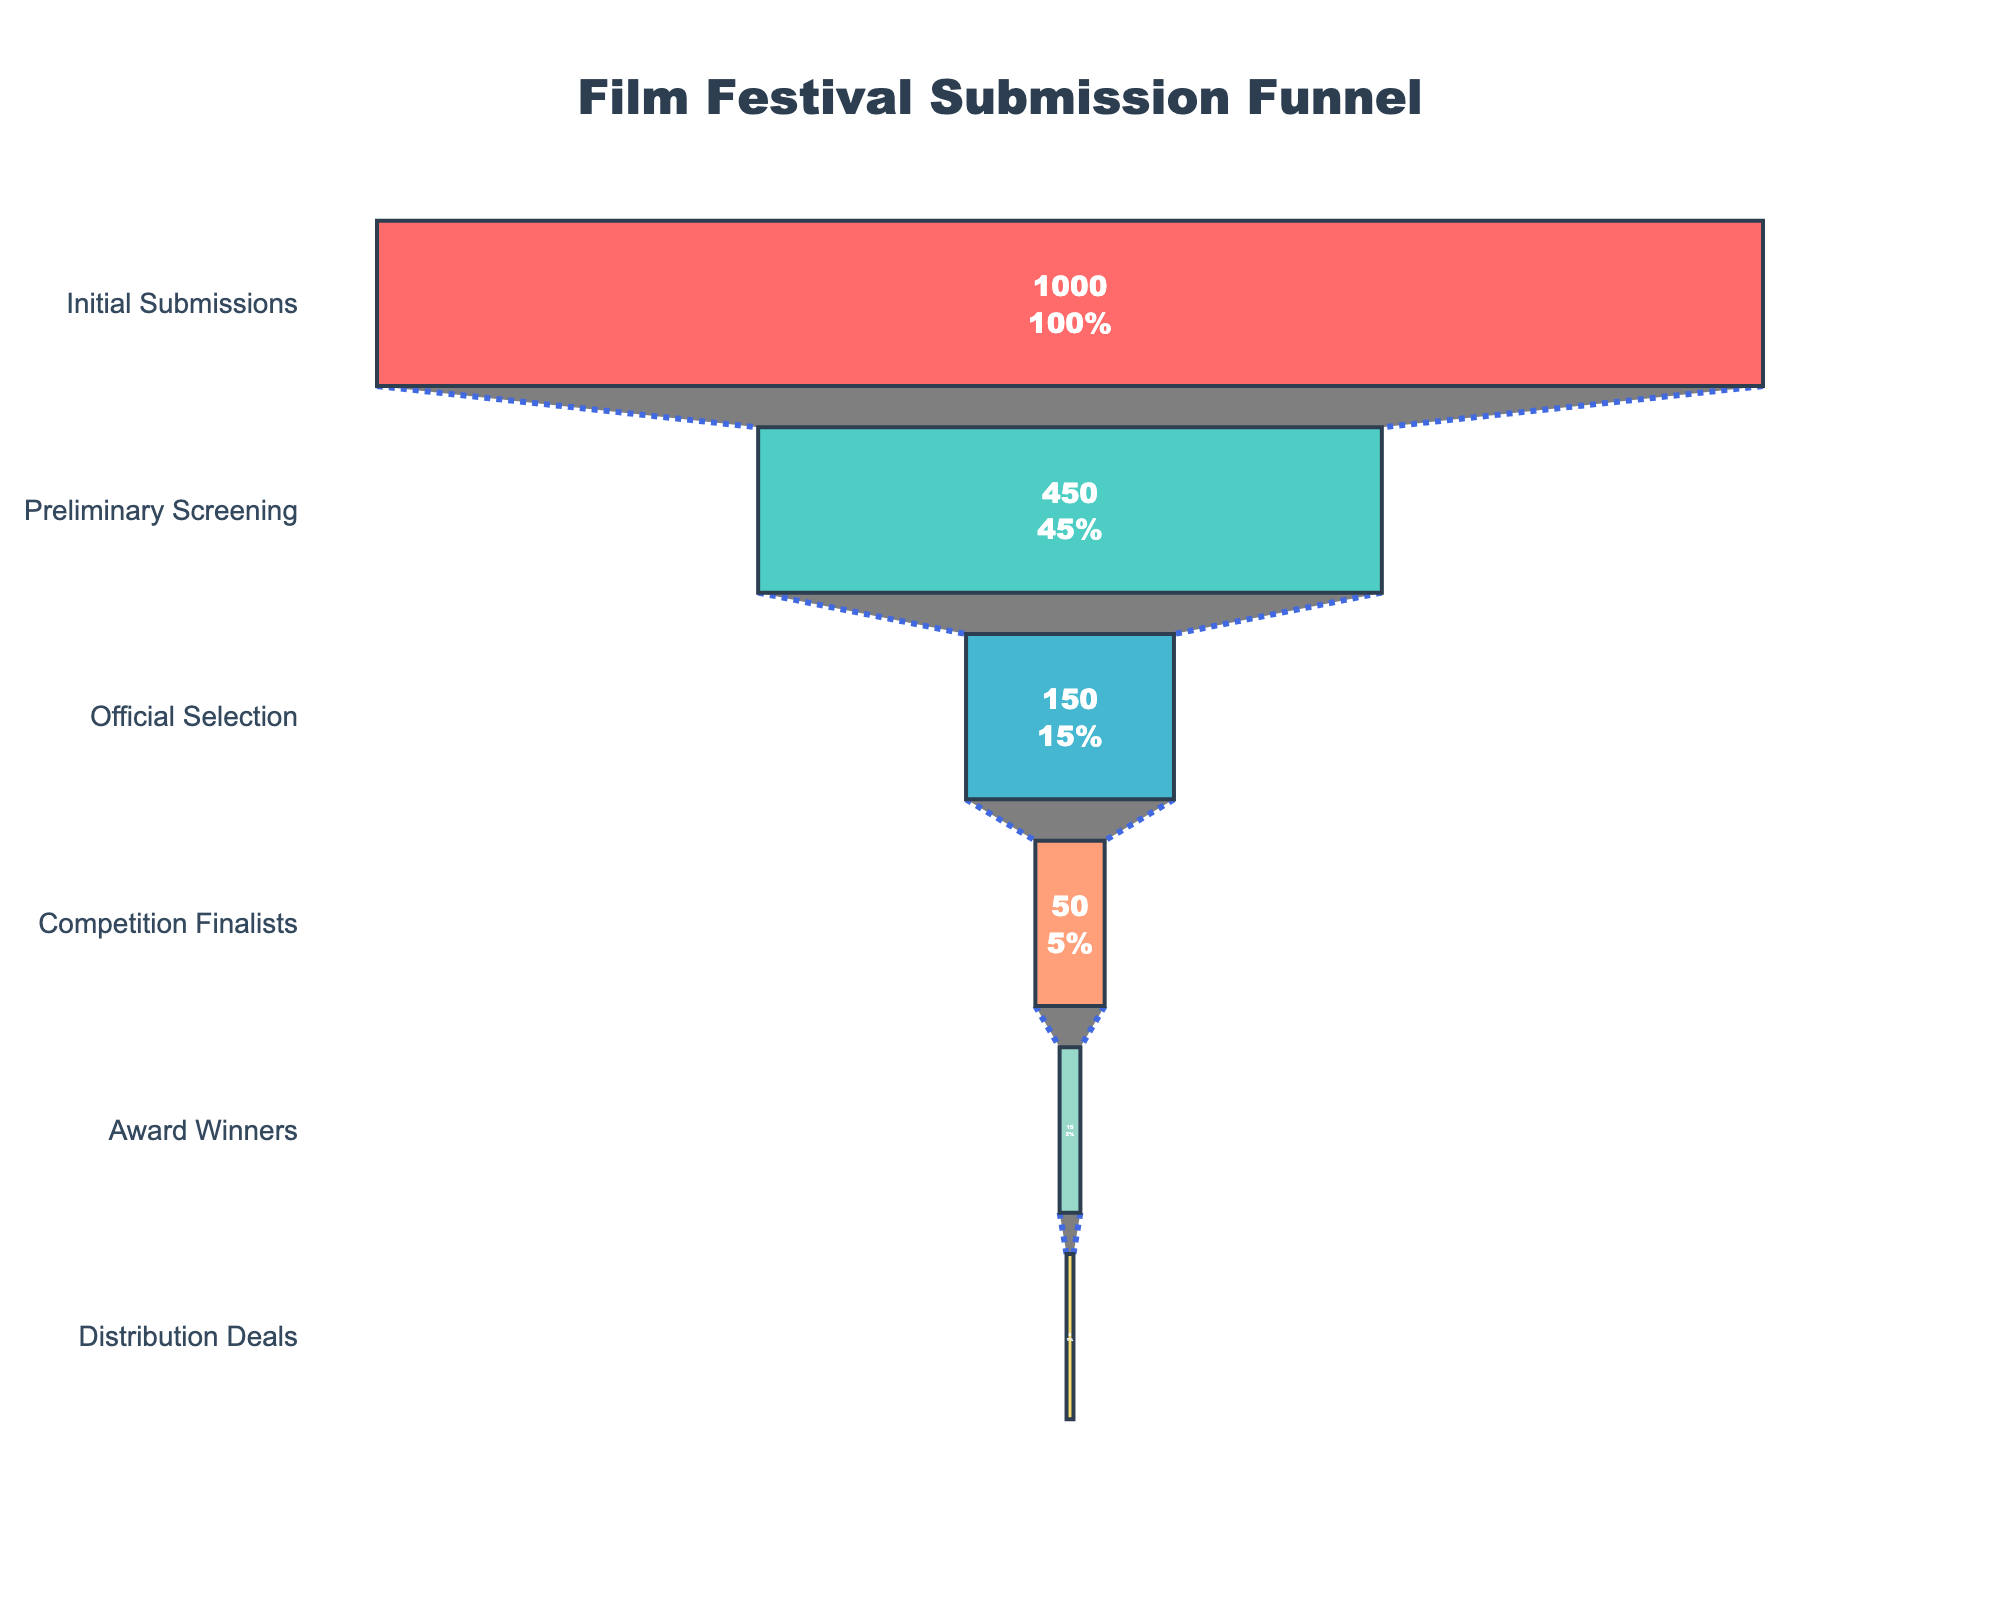What is the total number of films initially submitted to the festival? To find the total number of films initially submitted, look at the "Initial Submissions" stage in the funnel chart where the number is directly provided.
Answer: 1000 How many films made it to the official selection? To determine the number of films that made it to the official selection, refer to the "Official Selection" stage in the funnel chart where the number of films is mentioned.
Answer: 150 What is the success rate of films from initial submission to preliminary screening? Calculate the rate by dividing the number of films in the "Preliminary Screening" stage by the number of films in the "Initial Submissions" stage and multiply by 100 to get the percentage. Success rate = (450 / 1000) * 100.
Answer: 45% How many more films made it to preliminary screening compared to those that received distribution deals? Subtract the number of films at the "Distribution Deals" stage from the number at the "Preliminary Screening" stage. Difference = 450 - 5.
Answer: 445 What stage has the smallest percentage of films? Compare the percentages at each stage provided in the funnel chart. The smallest percentage is where the percentage value is the lowest.
Answer: Distribution Deals What is the overall success rate from initial submissions to award winners? Calculate the overall success rate by dividing the number of award winners by the number of initial submissions and multiplying by 100. Success rate = (15 / 1000) * 100.
Answer: 1.5% Which stage shows the biggest drop-off in the number of films? Determine where the largest numerical difference between consecutive stages occurs. Compare the differences between each stage: Initial to Preliminary (1000-450), Preliminary to Official (450-150), Official to Finalists (150-50), Finalists to Winners (50-15), Winners to Deals (15-5). The largest difference is between Initial Submissions and Preliminary Screening.
Answer: Preliminary Screening How many films go from official selection to competition finalists? Look at the numbers specifically provided for the "Official Selection" and "Competition Finalists" stages. Subtract the number of films in "Competition Finalists" from "Official Selection." Difference = 150 - 50.
Answer: 100 What is the percentage drop from competition finalists to award winners? Calculate the percentage drop by finding the difference between the number of competition finalists and award winners, divided by the number of competition finalists, multiplied by 100. Drop percentage = ((50 - 15) / 50) * 100.
Answer: 70% How many stages are represented in the funnel chart? Count the distinct stages listed on the y-axis of the funnel chart.
Answer: 6 